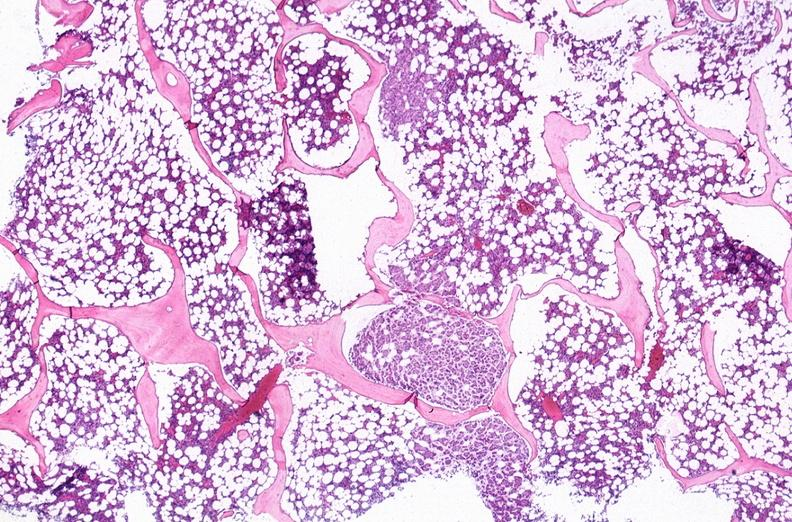does this image show breast cancer metastasis to bone marrow?
Answer the question using a single word or phrase. Yes 